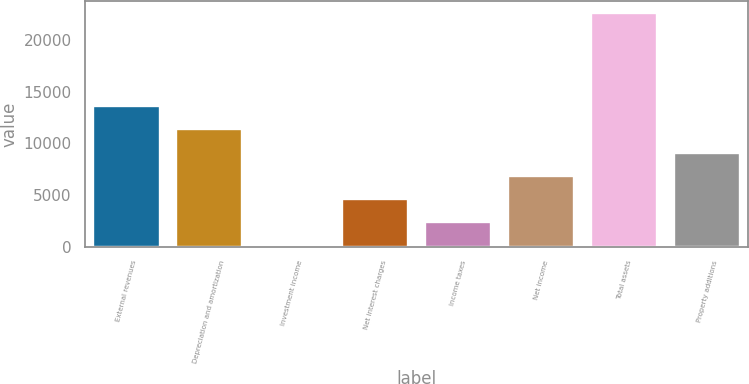Convert chart to OTSL. <chart><loc_0><loc_0><loc_500><loc_500><bar_chart><fcel>External revenues<fcel>Depreciation and amortization<fcel>Investment income<fcel>Net interest charges<fcel>Income taxes<fcel>Net income<fcel>Total assets<fcel>Property additions<nl><fcel>13608.6<fcel>11357.5<fcel>102<fcel>4604.2<fcel>2353.1<fcel>6855.3<fcel>22613<fcel>9106.4<nl></chart> 